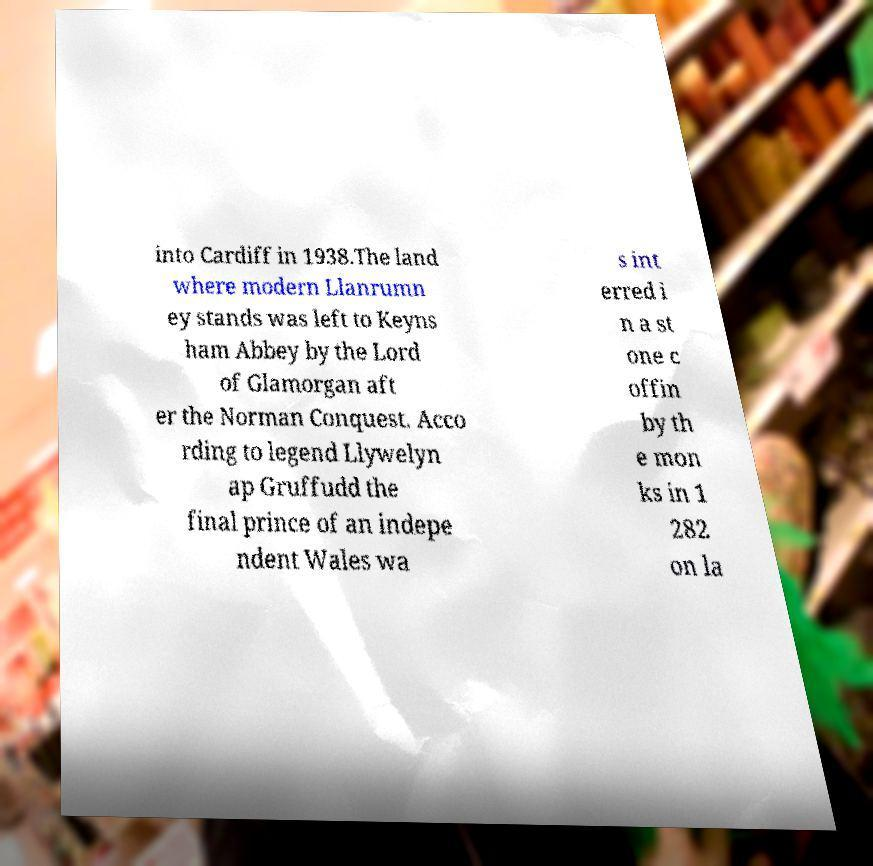Can you read and provide the text displayed in the image?This photo seems to have some interesting text. Can you extract and type it out for me? into Cardiff in 1938.The land where modern Llanrumn ey stands was left to Keyns ham Abbey by the Lord of Glamorgan aft er the Norman Conquest. Acco rding to legend Llywelyn ap Gruffudd the final prince of an indepe ndent Wales wa s int erred i n a st one c offin by th e mon ks in 1 282 on la 